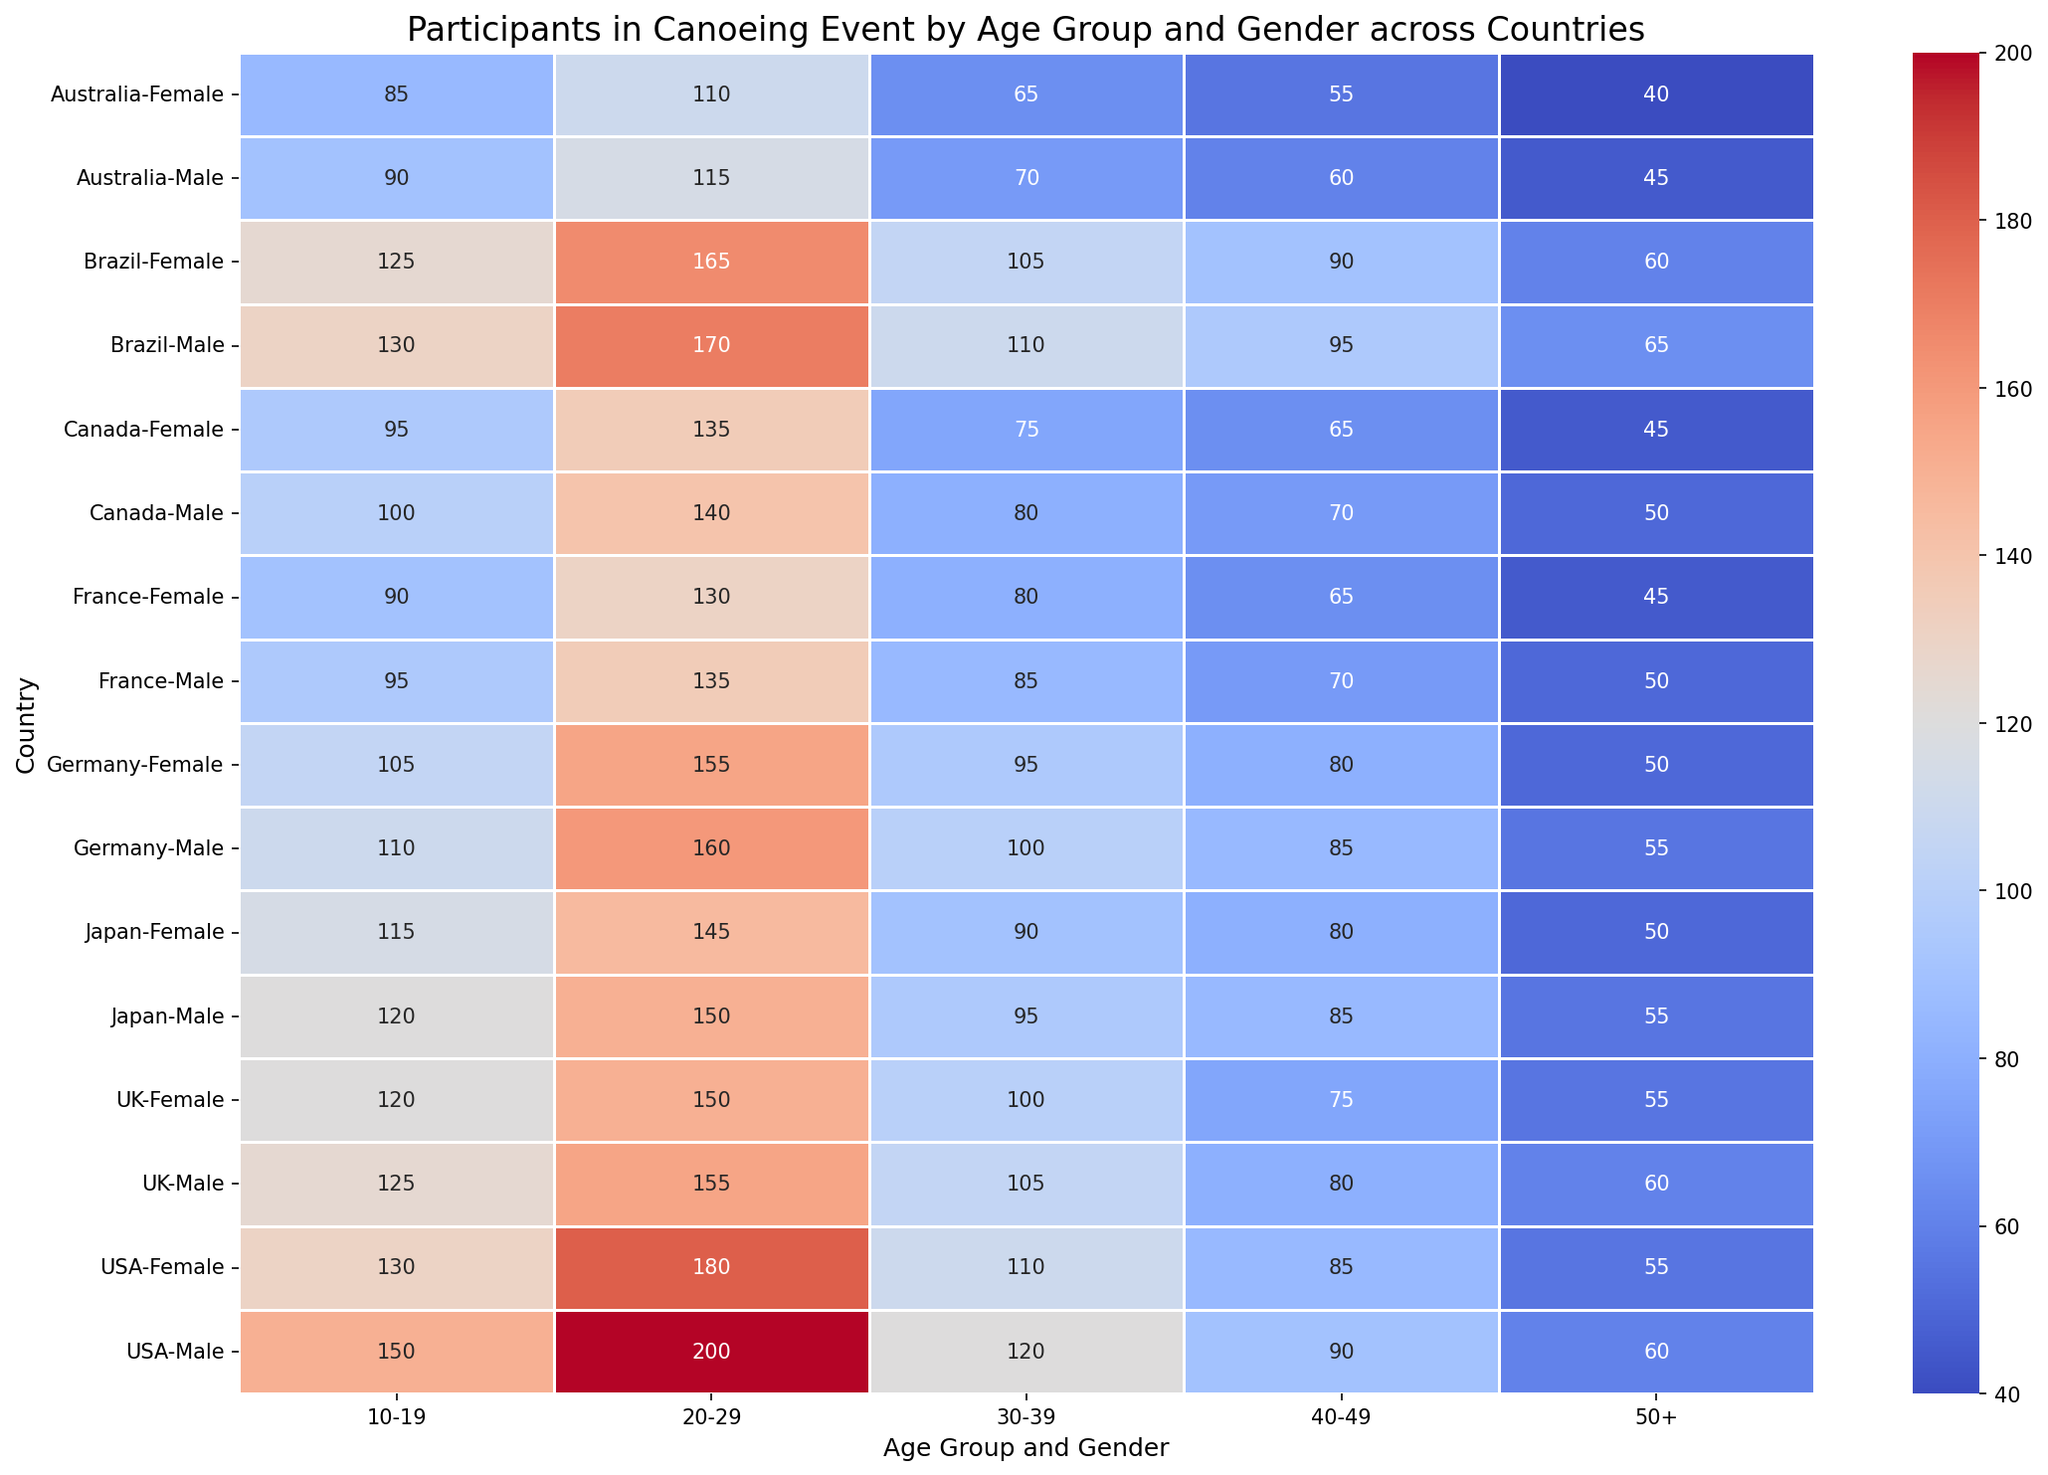Which country has the highest number of female participants in the 20-29 age group? By looking at the heatmap, identify the cell that represents female participants in the 20-29 age group for each country. The country with the highest value in that cell is the answer.
Answer: USA Between Canada and Australia, which country has more male participants in the 50+ age group? Compare the cell values for male participants in the 50+ age group between Canada and Australia. Canada has 50 and Australia has 45.
Answer: Canada Which age group has the highest number of male participants in Japan? Look at the values for all age groups under male participants for Japan. The highest value is in the 20-29 age group with 150 participants.
Answer: 20-29 How many total female participants are there in Brazil across all age groups? Sum the values for female participants across all age groups in Brazil: 125 (10-19) + 165 (20-29) + 105 (30-39) + 90 (40-49) + 60 (50+). This gives a total of 545.
Answer: 545 Compare the number of 10-19 age group participants of both genders in the UK. Which gender has more participants, and by how much? Check the values for male and female participants in the 10-19 age group for the UK. The number for males is 125 and for females is 120. Males have 5 more participants than females.
Answer: Male, by 5 What is the overall number of participants (both genders included) for the 30-39 age group in Germany and France combined? Add the values for both male and female participants in the 30-39 age group for both countries: Germany (100 + 95) + France (85 + 80). This equals 360 participants.
Answer: 360 Is the number of female participants in the 40-49 age group higher in the USA or in Germany? Compare the values for female participants in the 40-49 age group between the USA and Germany. USA has 85 and Germany has 80. Therefore, the USA has more.
Answer: USA Which country has the smallest number of total participants in the 50+ age group for both genders combined? Add up the male and female participants in the 50+ age group for each country. The smallest total is for Australia with 45 (male) + 40 (female) = 85.
Answer: Australia 